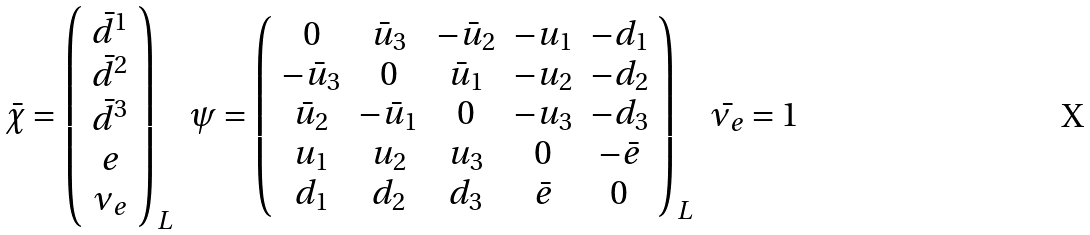Convert formula to latex. <formula><loc_0><loc_0><loc_500><loc_500>\begin{array} { c c c } \bar { \chi } = \left ( \begin{array} { c } \bar { d } ^ { 1 } \\ \bar { d } ^ { 2 } \\ \bar { d } ^ { 3 } \\ e \\ \nu _ { e } \end{array} \right ) _ { L } & \psi = \left ( \begin{array} { c c c c c } 0 & \bar { u } _ { 3 } & - \bar { u } _ { 2 } & - u _ { 1 } & - d _ { 1 } \\ - \bar { u } _ { 3 } & 0 & \bar { u } _ { 1 } & - u _ { 2 } & - d _ { 2 } \\ \bar { u } _ { 2 } & - \bar { u } _ { 1 } & 0 & - u _ { 3 } & - d _ { 3 } \\ u _ { 1 } & u _ { 2 } & u _ { 3 } & 0 & - \bar { e } \\ d _ { 1 } & d _ { 2 } & d _ { 3 } & \bar { e } & 0 \end{array} \right ) _ { L } & \bar { \nu _ { e } } = 1 \end{array}</formula> 